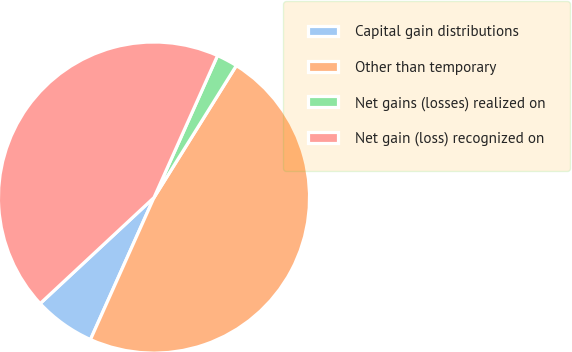Convert chart to OTSL. <chart><loc_0><loc_0><loc_500><loc_500><pie_chart><fcel>Capital gain distributions<fcel>Other than temporary<fcel>Net gains (losses) realized on<fcel>Net gain (loss) recognized on<nl><fcel>6.37%<fcel>47.82%<fcel>2.18%<fcel>43.63%<nl></chart> 